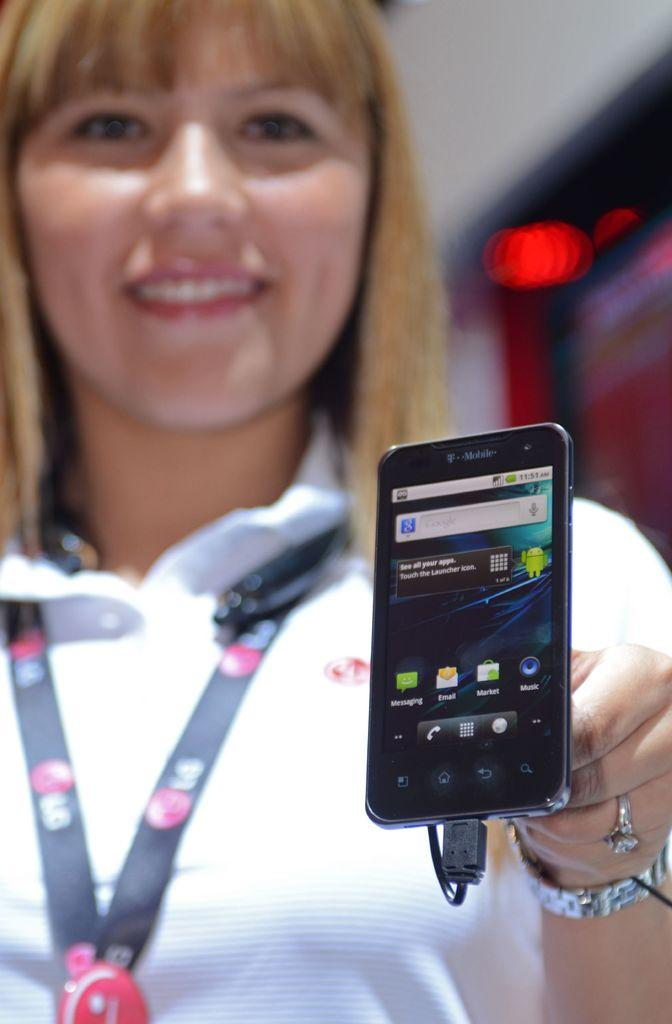Who is present in the image? There is a woman in the image. What is the woman wearing? The woman is wearing a tag. What is the woman holding in the image? The woman is holding a mobile. What can be seen on the mobile screen? The mobile screen displays applications. Can you describe the background of the image? The background of the image is blurry. What type of jellyfish can be seen swimming in the background of the image? There are no jellyfish present in the image; the background is blurry. Can you describe the frog that is sitting on the woman's shoulder in the image? There is no frog present in the image; the woman is holding a mobile. 